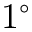<formula> <loc_0><loc_0><loc_500><loc_500>1 ^ { \circ }</formula> 